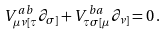Convert formula to latex. <formula><loc_0><loc_0><loc_500><loc_500>V _ { \mu \nu [ \tau } ^ { a b } \partial _ { \sigma ] } + V _ { \tau \sigma [ \mu } ^ { b a } \partial _ { \nu ] } = 0 \, .</formula> 